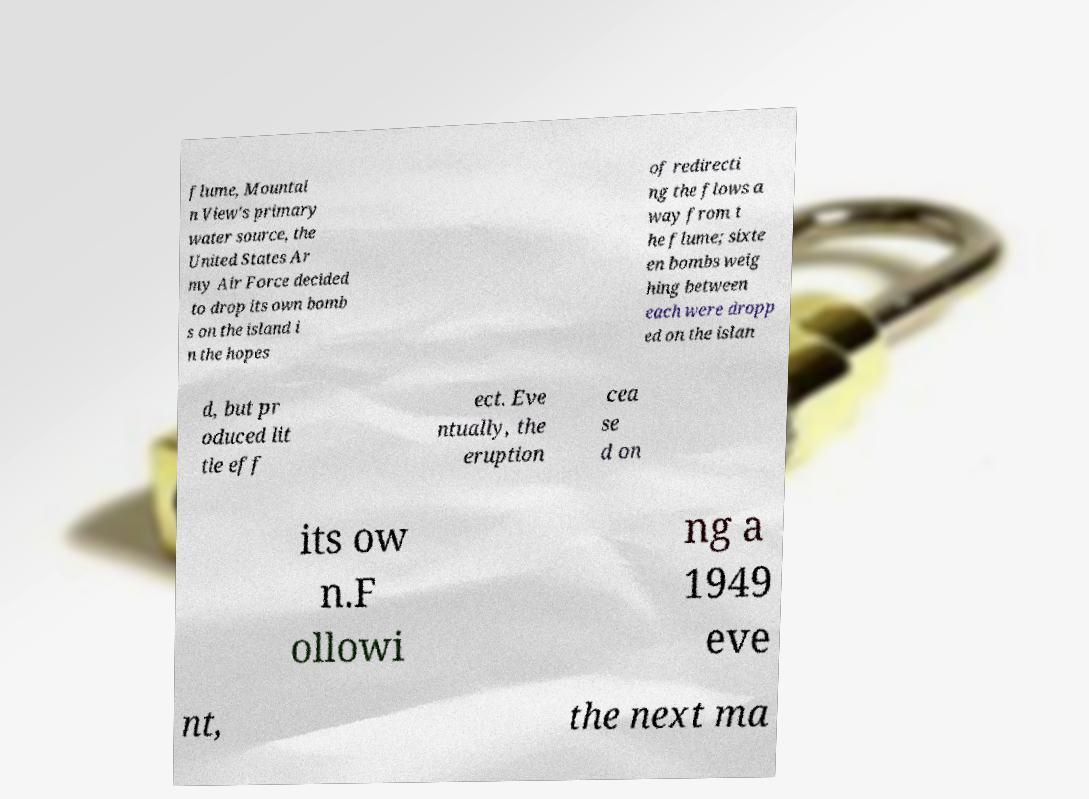Please identify and transcribe the text found in this image. flume, Mountai n View's primary water source, the United States Ar my Air Force decided to drop its own bomb s on the island i n the hopes of redirecti ng the flows a way from t he flume; sixte en bombs weig hing between each were dropp ed on the islan d, but pr oduced lit tle eff ect. Eve ntually, the eruption cea se d on its ow n.F ollowi ng a 1949 eve nt, the next ma 